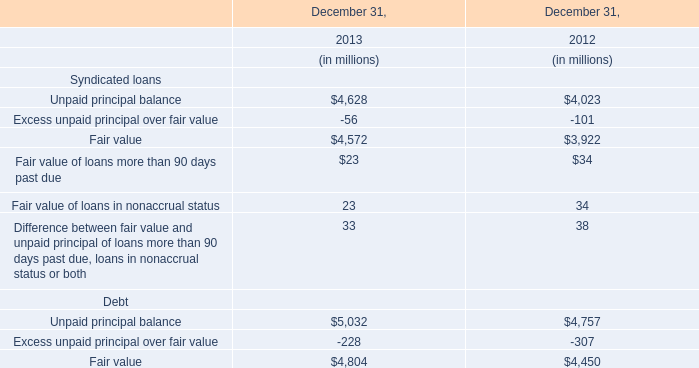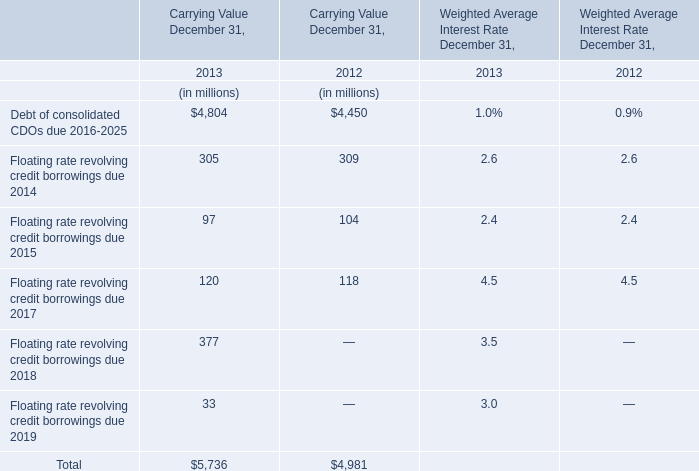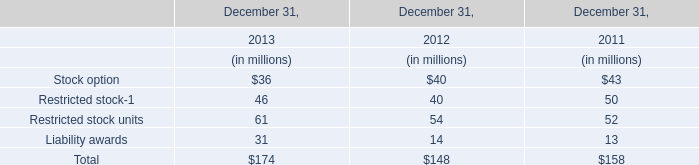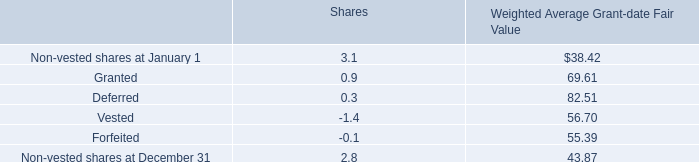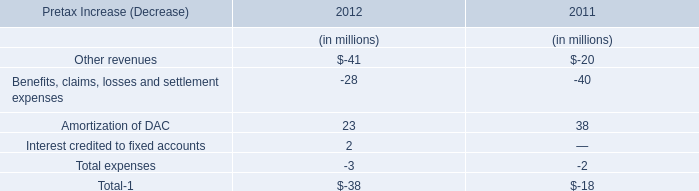What is the ratio of carrying value of Debt of consolidated CDOs due 2016-2025 to the total in 2013? 
Computations: (4804 / 5736)
Answer: 0.83752. 